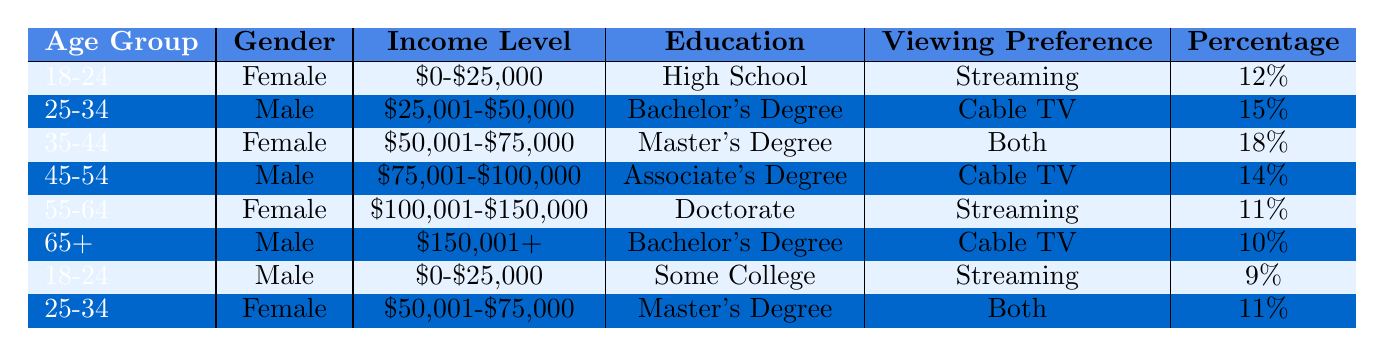What percentage of the 35-44 female demographic prefers watching both streaming and cable TV? In the table, the 35-44 age group for females has a viewing preference of "Both" and is listed with a percentage of 18%.
Answer: 18% Which income range has the highest viewing preference for cable TV? The 25-34 male demographic with an income range of $25,001-$50,000 and the 45-54 male demographic with an income range of $75,001-$100,000 both prefer cable TV. However, the question asks for the demographic with the highest percentage, which is the 25-34 male at 15%.
Answer: $25,001-$50,000 Is there a demographic with more than 15% viewing preference for streaming among females aged 18-24? The 18-24 females prefer streaming at 12%, which is not more than 15%. Thus, there is no demographic under 18-24 females with more than 15% preference for streaming.
Answer: No What is the total percentage of males who prefer cable TV? From the data, males who prefer cable TV are in two groups: the 25-34 male (15%) and the 45-54 male (14%), and 65+ male (10%). Adding these percentages gives 15% + 14% + 10% = 39%.
Answer: 39% Which age group has the lowest percentage preference for streaming, and what is that percentage? The age group of 55-64 females has a percentage of 11% for streaming, which is the lowest among all groups listed preference for streaming.
Answer: 11% Are there more females or males in the age group 25-34? The table shows one female (11% for "Both") and one male (15% for "Cable TV") in the 25-34 age group. Thus, males have a higher percentage in this age category.
Answer: Males What is the median income level of all demographics listed in the table? To find the median, we list the income categories in increasing order based on the available data: $0-$25,000, $0-$25,000, $25,001-$50,000, $50,001-$75,000, $50,001-$75,000, $75,001-$100,000, $100,001-$150,000, $150,001+. There are eight categories, so median is between the 4th and 5th: $50,001-$75,000.
Answer: $50,001-$75,000 